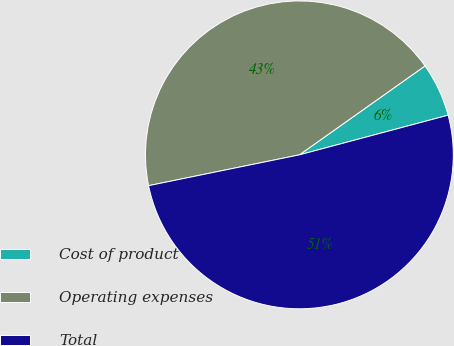Convert chart to OTSL. <chart><loc_0><loc_0><loc_500><loc_500><pie_chart><fcel>Cost of product<fcel>Operating expenses<fcel>Total<nl><fcel>5.66%<fcel>43.4%<fcel>50.94%<nl></chart> 